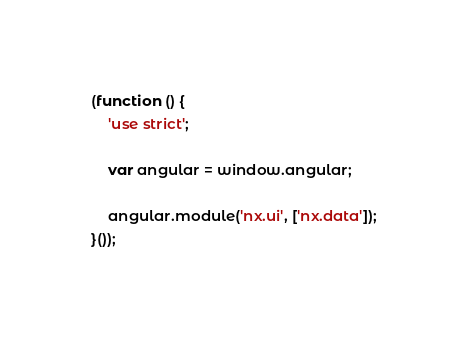Convert code to text. <code><loc_0><loc_0><loc_500><loc_500><_JavaScript_>(function () {
    'use strict';

    var angular = window.angular;

    angular.module('nx.ui', ['nx.data']);
}());


</code> 